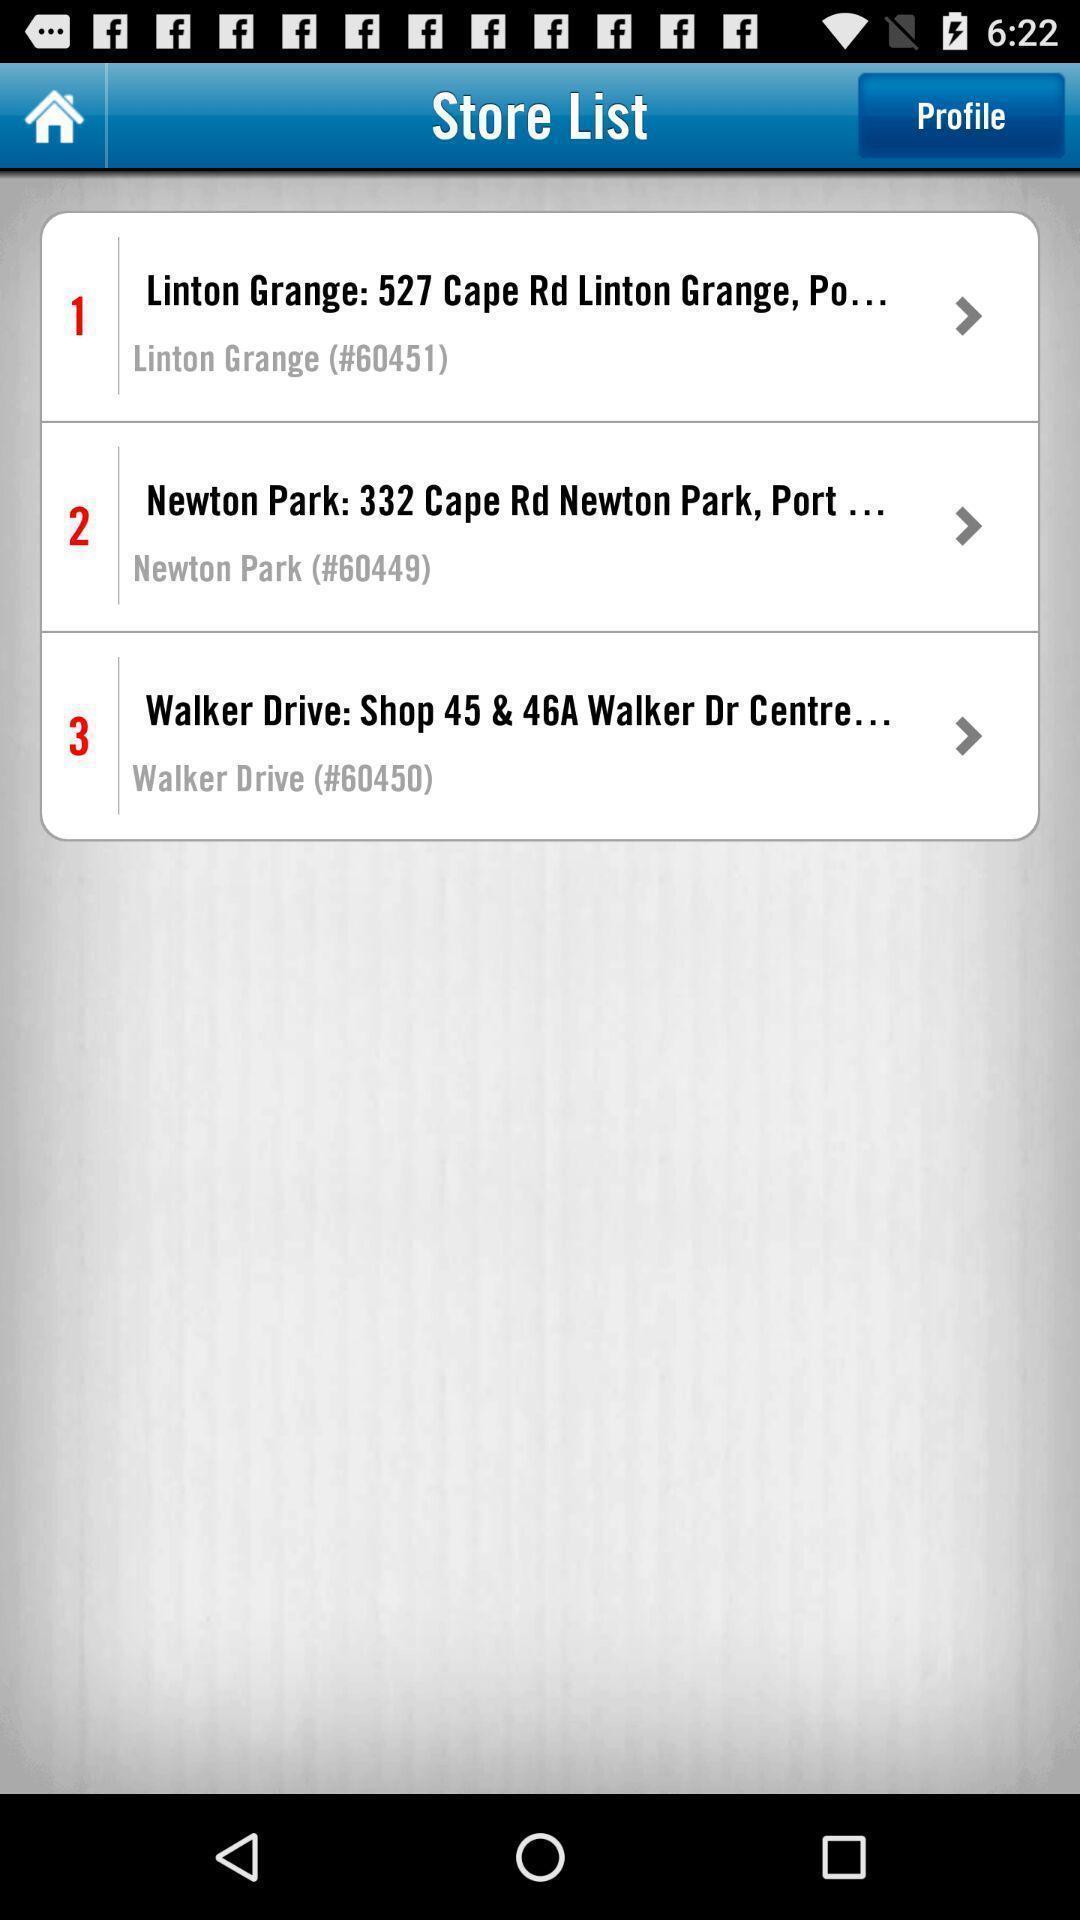Please provide a description for this image. Various list displayed. 